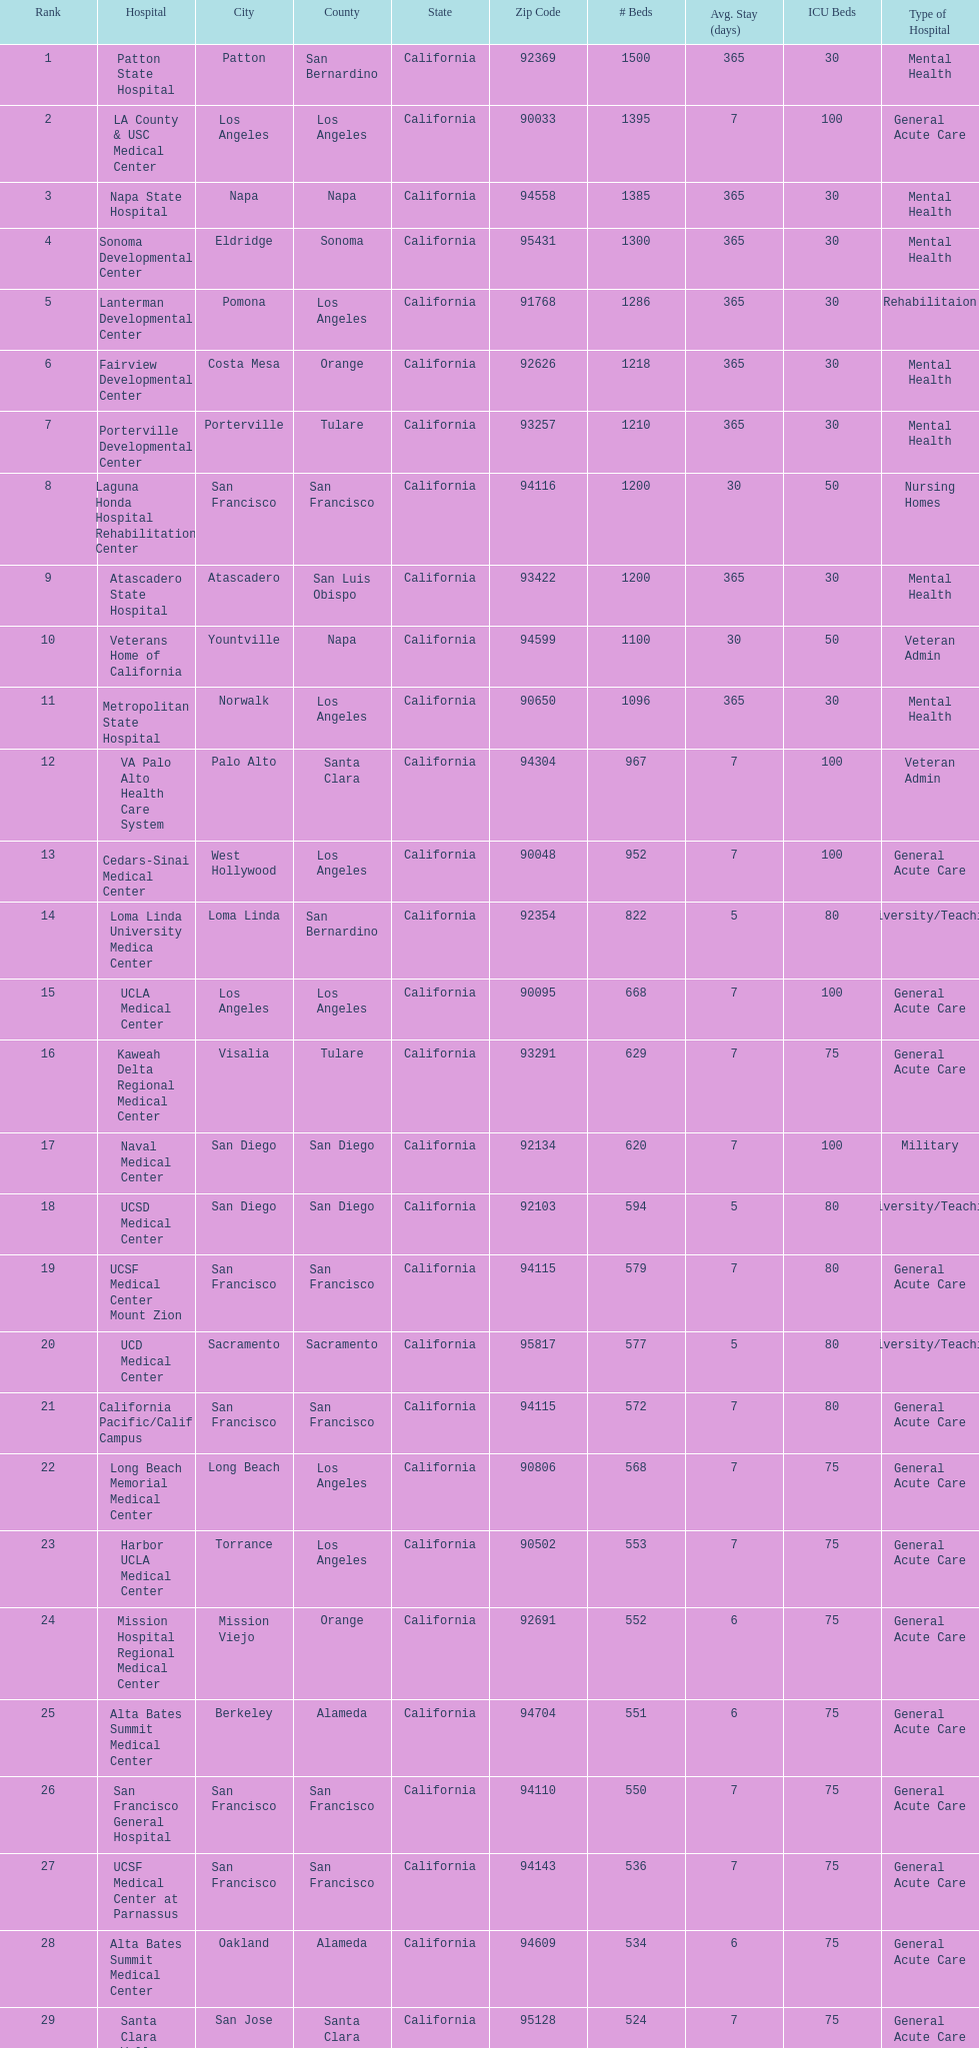What two hospitals holding consecutive rankings of 8 and 9 respectively, both provide 1200 hospital beds? Laguna Honda Hospital Rehabilitation Center, Atascadero State Hospital. 